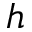<formula> <loc_0><loc_0><loc_500><loc_500>h</formula> 